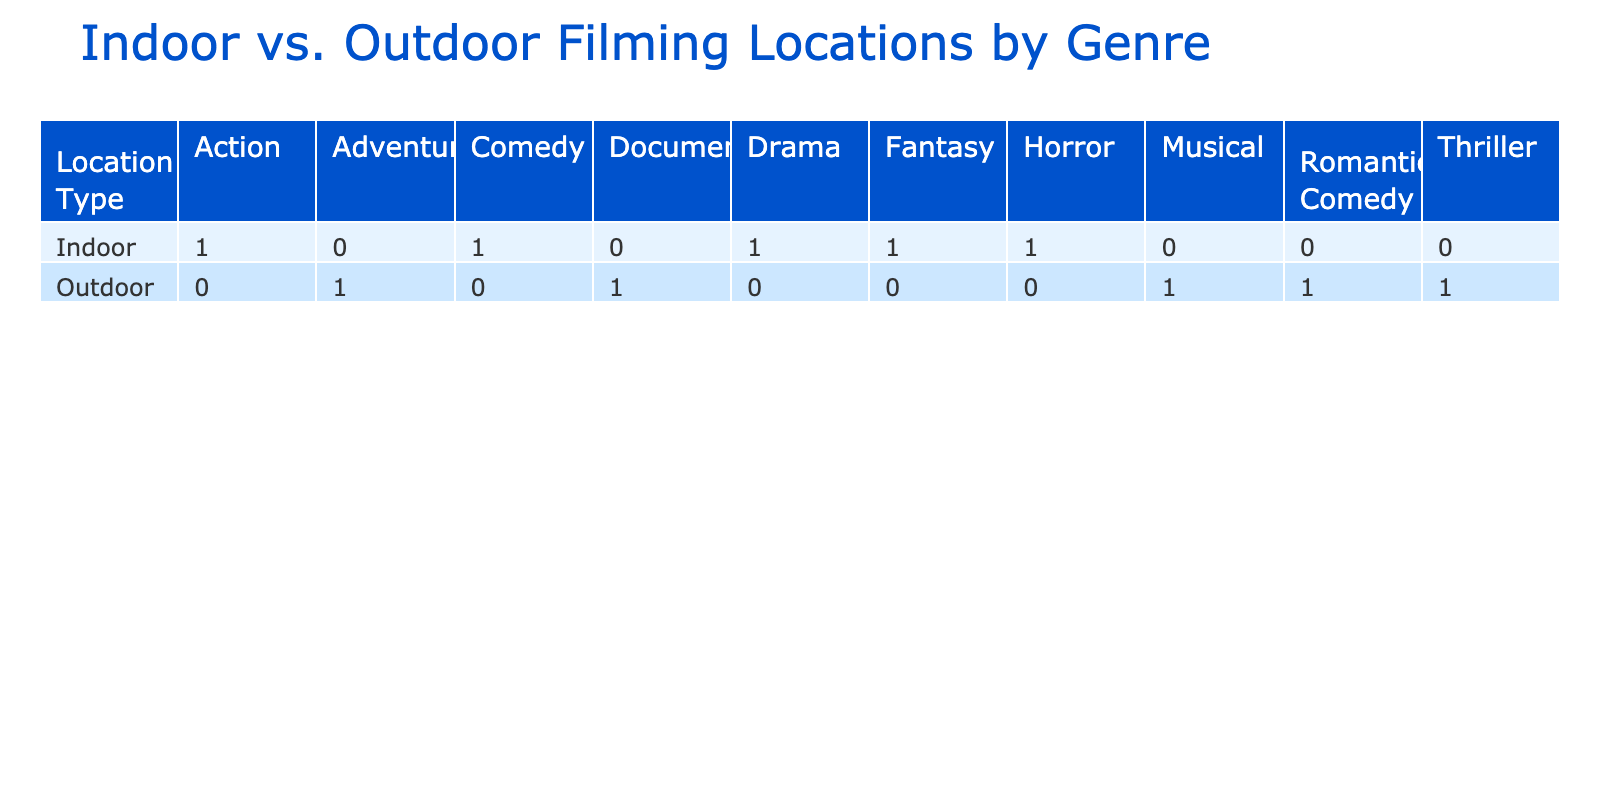What is the total number of films shot in outdoor locations? To find the total number of films shot in outdoor locations, we sum the "Number_of_Films_Shot" for all outdoor locations listed in the table: 10 (Yosemite National Park) + 15 (Central Park) + 7 (The Grand Canyon) + 4 (Hollywood Hills) + 6 (Dollywood) = 42.
Answer: 42 How many horror films were shot in indoor locations? The table shows that only "The Stanley Hotel" is listed under the horror genre in indoor locations, with 5 films shot there.
Answer: 5 Is "The Getty Center" an outdoor filming location? "The Getty Center" is listed under indoor filming locations in the table, indicating it is not an outdoor filming location.
Answer: No What is the average production budget for indoor films? To calculate the average production budget for indoor films, we sum the production budgets of the indoor locations: 20M (The Stanley Hotel) + 15M (The Getty Center) + 50M (Warner Bros. Studios) + 12M (The Phantom Lake Conference Center) + 10M (Botanic Gardens) = 107M. There are 5 indoor locations, so the average = 107M / 5 = 21.4M.
Answer: 21.4 million USD Which filming location has the highest number of films shot in outdoor settings? From reviewing the outdoor filming locations, it is evident that "Central Park" has the highest number of films shot, totaling 15.
Answer: Central Park 